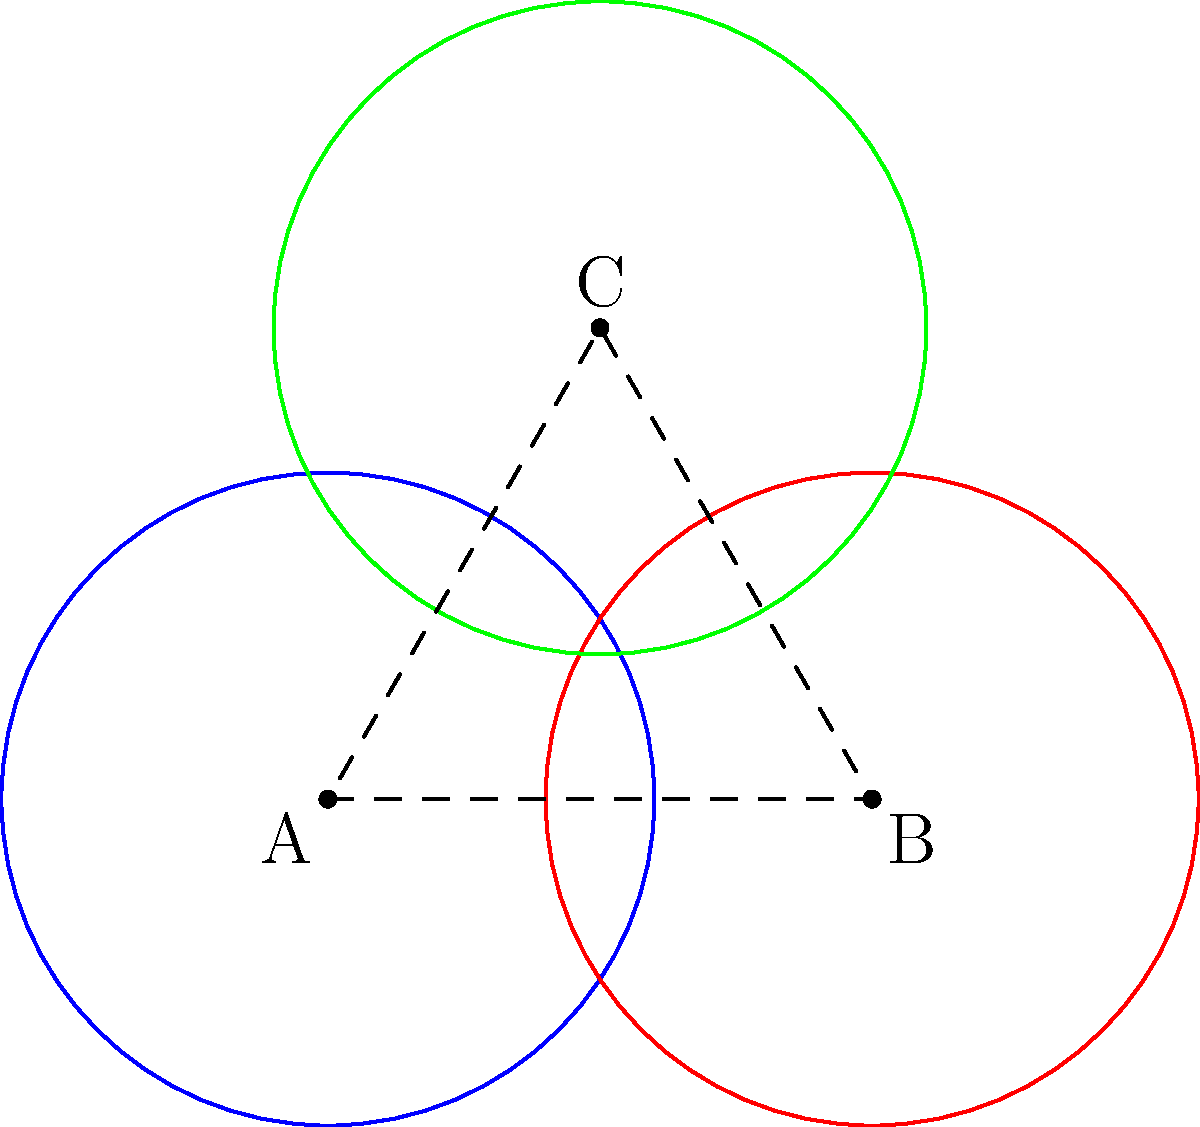For the sports day event, you need to arrange three circular buffet tables, each with a radius of 3 meters. The centers of the tables form an equilateral triangle with side length 5 meters. Using vector representation, calculate the total area covered by the three tables, including any overlapping regions. Round your answer to the nearest square meter. Let's approach this step-by-step:

1) First, we need to set up our vector representation. Let's place the center of the first table at the origin (0,0), the second table at (5,0), and the third table at (2.5, 4.33). The third point is calculated using the properties of an equilateral triangle.

2) We can represent these points as vectors:
   $\vec{A} = (0, 0)$
   $\vec{B} = (5, 0)$
   $\vec{C} = (2.5, 4.33)$

3) The area of a single circle is $\pi r^2 = \pi (3^2) = 9\pi$ square meters.

4) If the circles didn't overlap, the total area would be $3(9\pi) = 27\pi$ square meters.

5) To find the overlapping area, we need to calculate the distance between the centers:
   $|\vec{B} - \vec{A}| = |\vec{C} - \vec{B}| = |\vec{A} - \vec{C}| = 5$ meters

6) The overlapping area between two circles can be calculated using the formula:
   $A = 2r^2 \arccos(\frac{d}{2r}) - d\sqrt{r^2 - (\frac{d}{2})^2}$
   where $r$ is the radius and $d$ is the distance between centers.

7) Substituting our values:
   $A = 2(3^2) \arccos(\frac{5}{2(3)}) - 5\sqrt{3^2 - (\frac{5}{2})^2}$
   $= 18 \arccos(\frac{5}{6}) - 5\sqrt{9 - \frac{25}{4}}$
   $\approx 2.72$ square meters

8) There are three such overlapping areas, so the total overlapping area is $3(2.72) = 8.16$ square meters.

9) Therefore, the total area covered is:
   $27\pi - 8.16 \approx 76.69$ square meters

10) Rounding to the nearest square meter gives us 77 square meters.
Answer: 77 square meters 